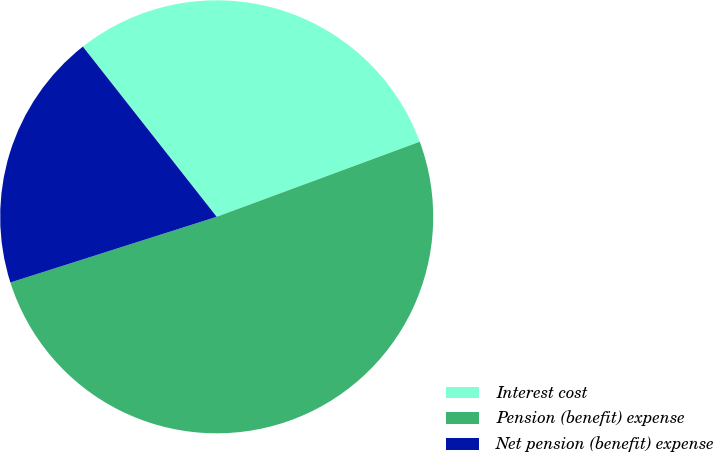<chart> <loc_0><loc_0><loc_500><loc_500><pie_chart><fcel>Interest cost<fcel>Pension (benefit) expense<fcel>Net pension (benefit) expense<nl><fcel>29.97%<fcel>50.73%<fcel>19.3%<nl></chart> 